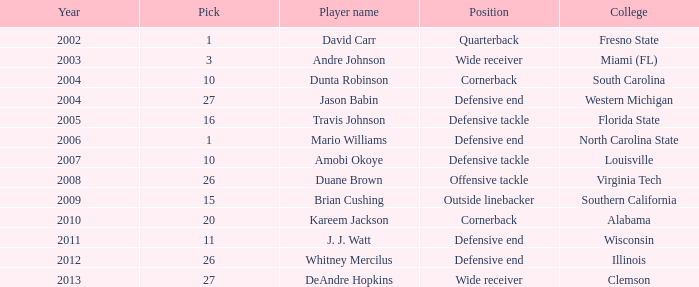Could you parse the entire table as a dict? {'header': ['Year', 'Pick', 'Player name', 'Position', 'College'], 'rows': [['2002', '1', 'David Carr', 'Quarterback', 'Fresno State'], ['2003', '3', 'Andre Johnson', 'Wide receiver', 'Miami (FL)'], ['2004', '10', 'Dunta Robinson', 'Cornerback', 'South Carolina'], ['2004', '27', 'Jason Babin', 'Defensive end', 'Western Michigan'], ['2005', '16', 'Travis Johnson', 'Defensive tackle', 'Florida State'], ['2006', '1', 'Mario Williams', 'Defensive end', 'North Carolina State'], ['2007', '10', 'Amobi Okoye', 'Defensive tackle', 'Louisville'], ['2008', '26', 'Duane Brown', 'Offensive tackle', 'Virginia Tech'], ['2009', '15', 'Brian Cushing', 'Outside linebacker', 'Southern California'], ['2010', '20', 'Kareem Jackson', 'Cornerback', 'Alabama'], ['2011', '11', 'J. J. Watt', 'Defensive end', 'Wisconsin'], ['2012', '26', 'Whitney Mercilus', 'Defensive end', 'Illinois'], ['2013', '27', 'DeAndre Hopkins', 'Wide receiver', 'Clemson']]} What pick was mario williams before 2006? None. 